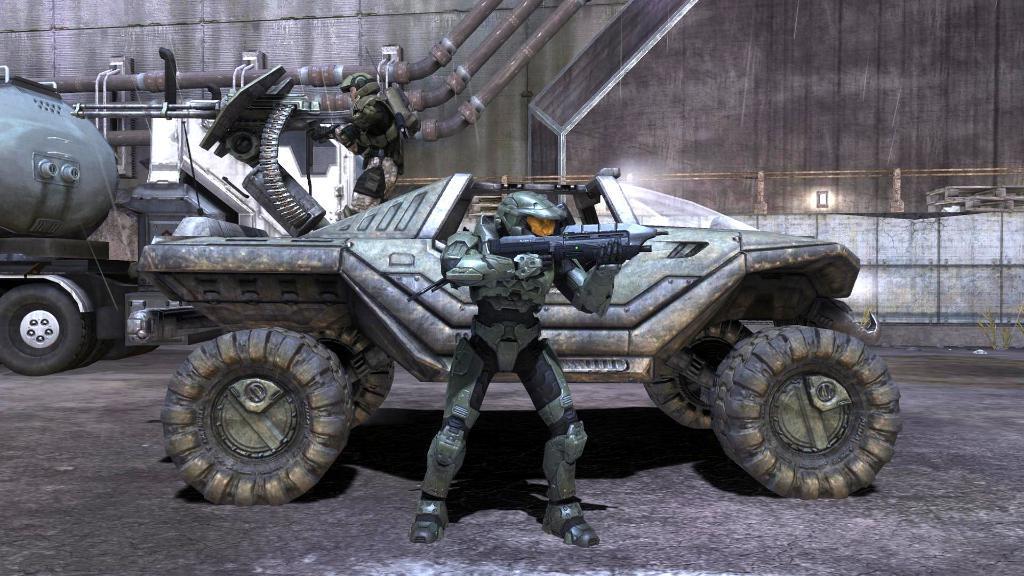Describe this image in one or two sentences. Here this picture is an animated image, in which we can see vehicles present and we can also see a person in an armor holding a gun. 